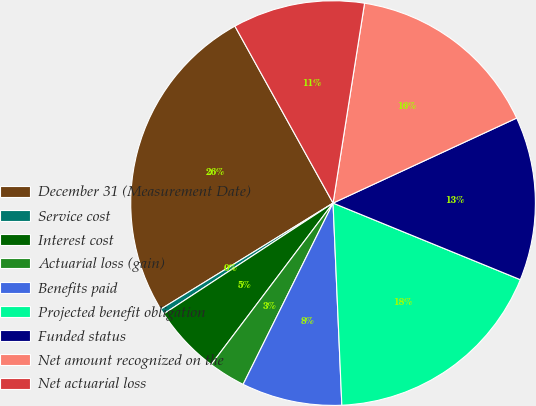<chart> <loc_0><loc_0><loc_500><loc_500><pie_chart><fcel>December 31 (Measurement Date)<fcel>Service cost<fcel>Interest cost<fcel>Actuarial loss (gain)<fcel>Benefits paid<fcel>Projected benefit obligation<fcel>Funded status<fcel>Net amount recognized on the<fcel>Net actuarial loss<nl><fcel>25.72%<fcel>0.44%<fcel>5.49%<fcel>2.96%<fcel>8.02%<fcel>18.13%<fcel>13.08%<fcel>15.61%<fcel>10.55%<nl></chart> 